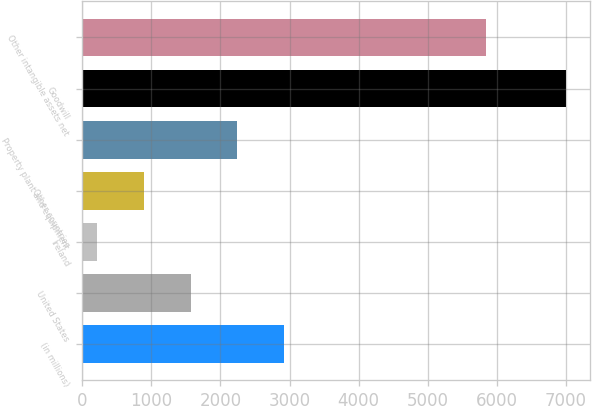<chart> <loc_0><loc_0><loc_500><loc_500><bar_chart><fcel>(in millions)<fcel>United States<fcel>Ireland<fcel>Other countries<fcel>Property plant and equipment<fcel>Goodwill<fcel>Other intangible assets net<nl><fcel>2925.2<fcel>1567.6<fcel>210<fcel>888.8<fcel>2246.4<fcel>6998<fcel>5837<nl></chart> 